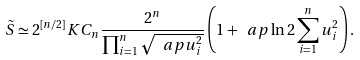Convert formula to latex. <formula><loc_0><loc_0><loc_500><loc_500>\tilde { S } \simeq 2 ^ { [ n / 2 ] } K C _ { n } \frac { 2 ^ { n } } { \prod _ { i = 1 } ^ { n } \sqrt { \ a p u _ { i } ^ { 2 } } } \left ( 1 + \ a p \ln 2 \sum _ { i = 1 } ^ { n } u _ { i } ^ { 2 } \right ) .</formula> 